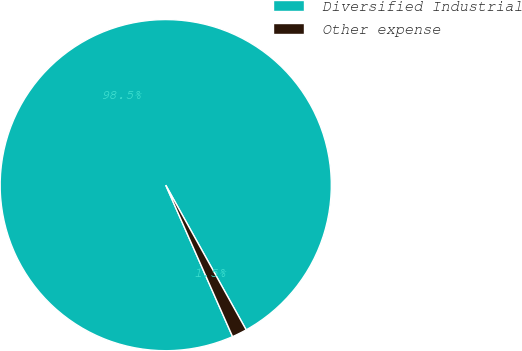Convert chart to OTSL. <chart><loc_0><loc_0><loc_500><loc_500><pie_chart><fcel>Diversified Industrial<fcel>Other expense<nl><fcel>98.54%<fcel>1.46%<nl></chart> 